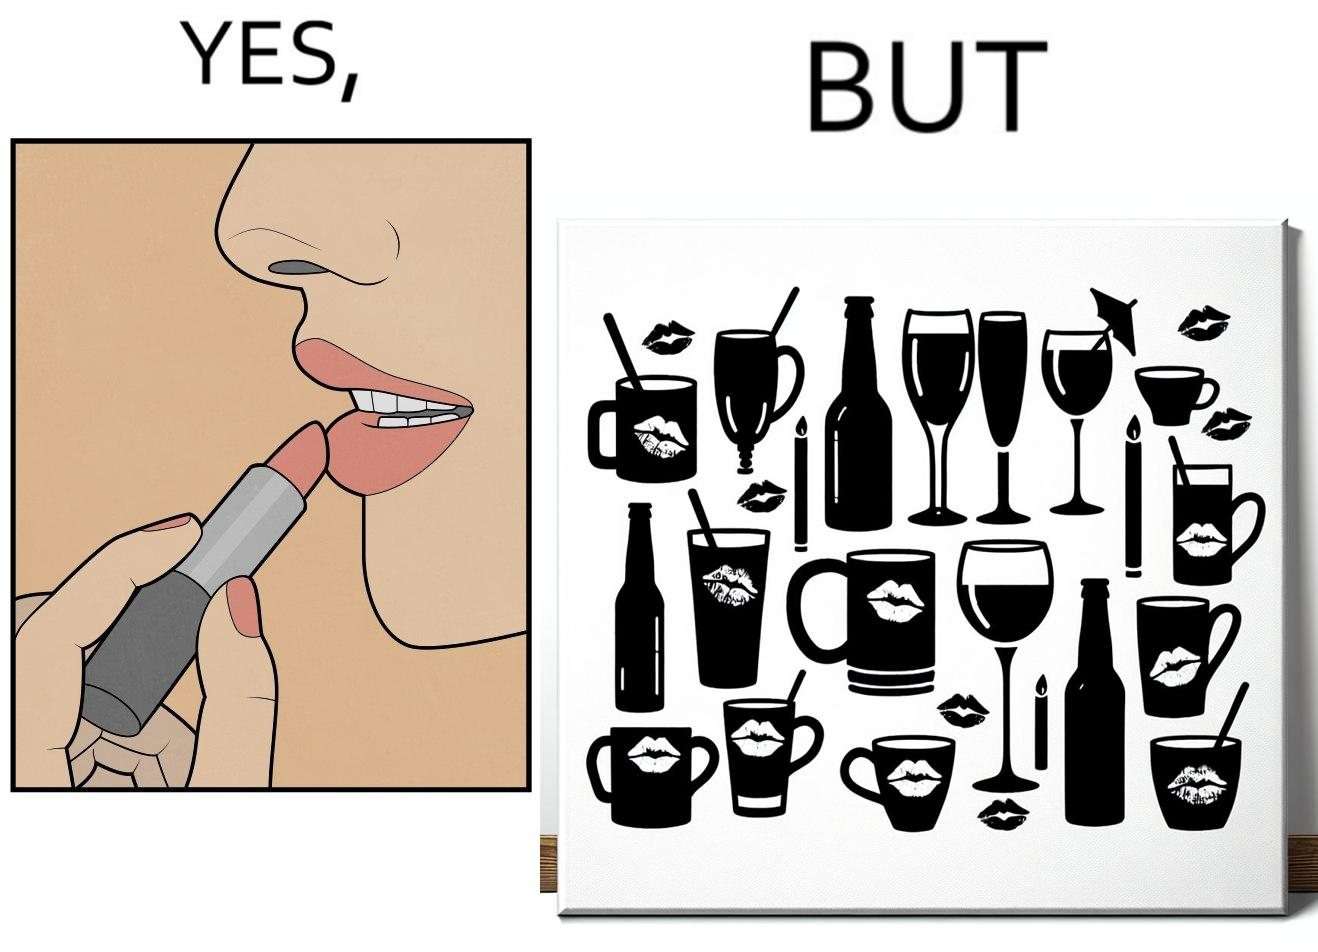Is there satirical content in this image? Yes, this image is satirical. 